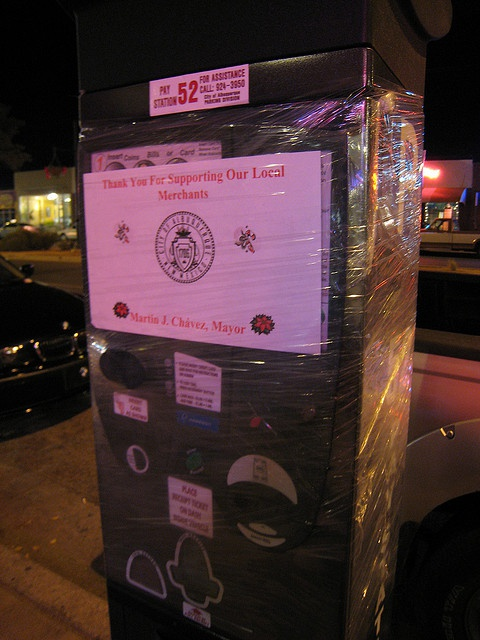Describe the objects in this image and their specific colors. I can see parking meter in black, violet, and maroon tones, car in black, maroon, and gray tones, car in black, maroon, and olive tones, car in black, maroon, and brown tones, and car in black, olive, and maroon tones in this image. 